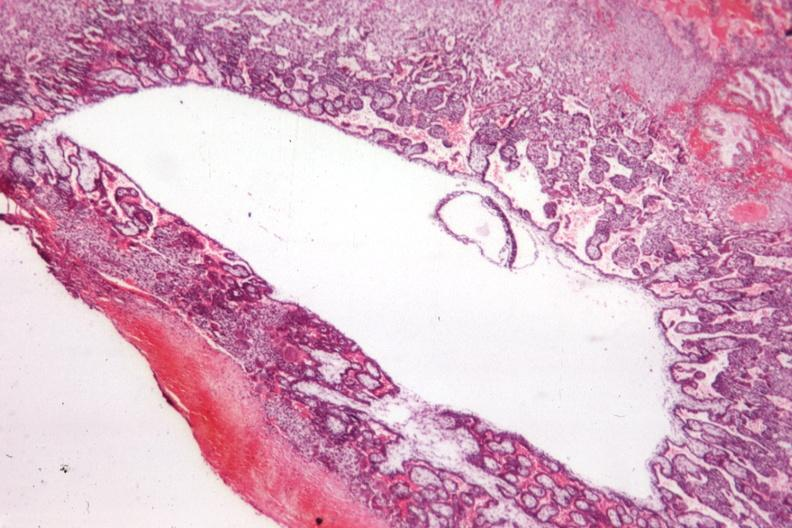s angiogram saphenous vein bypass graft present?
Answer the question using a single word or phrase. No 